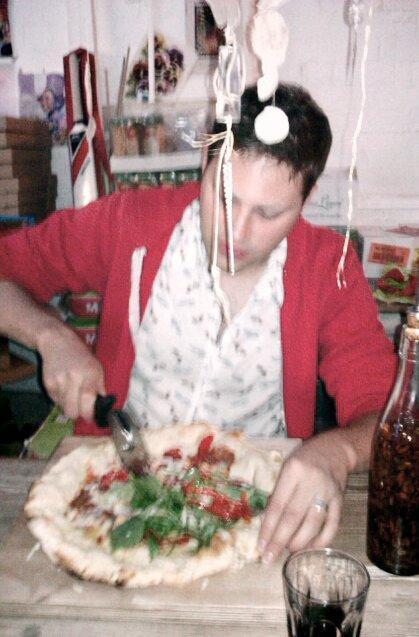How many slices is she cutting?
Give a very brief answer. 8. How many people are in the picture?
Give a very brief answer. 1. How many buses are red and white striped?
Give a very brief answer. 0. 